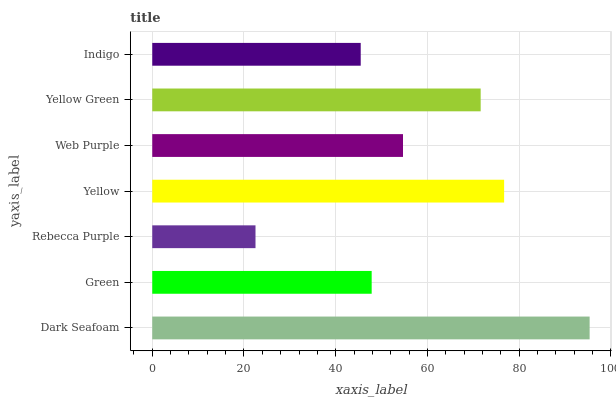Is Rebecca Purple the minimum?
Answer yes or no. Yes. Is Dark Seafoam the maximum?
Answer yes or no. Yes. Is Green the minimum?
Answer yes or no. No. Is Green the maximum?
Answer yes or no. No. Is Dark Seafoam greater than Green?
Answer yes or no. Yes. Is Green less than Dark Seafoam?
Answer yes or no. Yes. Is Green greater than Dark Seafoam?
Answer yes or no. No. Is Dark Seafoam less than Green?
Answer yes or no. No. Is Web Purple the high median?
Answer yes or no. Yes. Is Web Purple the low median?
Answer yes or no. Yes. Is Yellow the high median?
Answer yes or no. No. Is Rebecca Purple the low median?
Answer yes or no. No. 